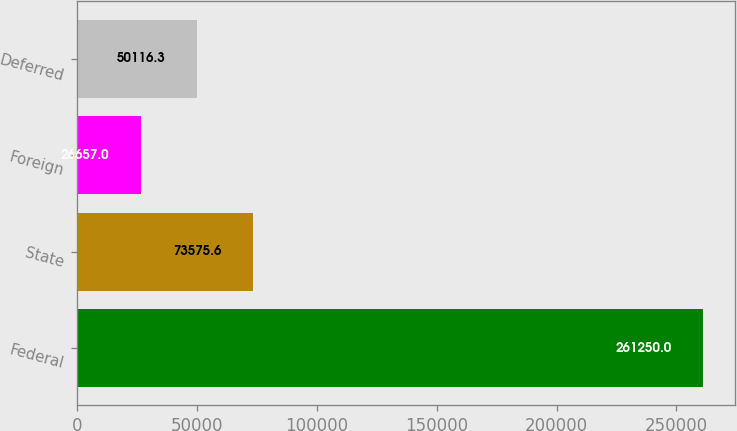Convert chart to OTSL. <chart><loc_0><loc_0><loc_500><loc_500><bar_chart><fcel>Federal<fcel>State<fcel>Foreign<fcel>Deferred<nl><fcel>261250<fcel>73575.6<fcel>26657<fcel>50116.3<nl></chart> 